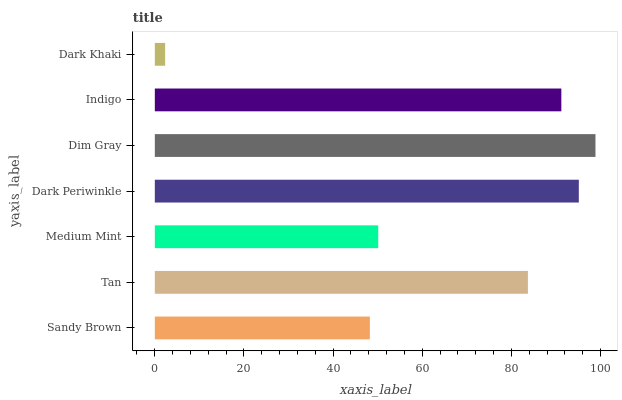Is Dark Khaki the minimum?
Answer yes or no. Yes. Is Dim Gray the maximum?
Answer yes or no. Yes. Is Tan the minimum?
Answer yes or no. No. Is Tan the maximum?
Answer yes or no. No. Is Tan greater than Sandy Brown?
Answer yes or no. Yes. Is Sandy Brown less than Tan?
Answer yes or no. Yes. Is Sandy Brown greater than Tan?
Answer yes or no. No. Is Tan less than Sandy Brown?
Answer yes or no. No. Is Tan the high median?
Answer yes or no. Yes. Is Tan the low median?
Answer yes or no. Yes. Is Dark Khaki the high median?
Answer yes or no. No. Is Medium Mint the low median?
Answer yes or no. No. 